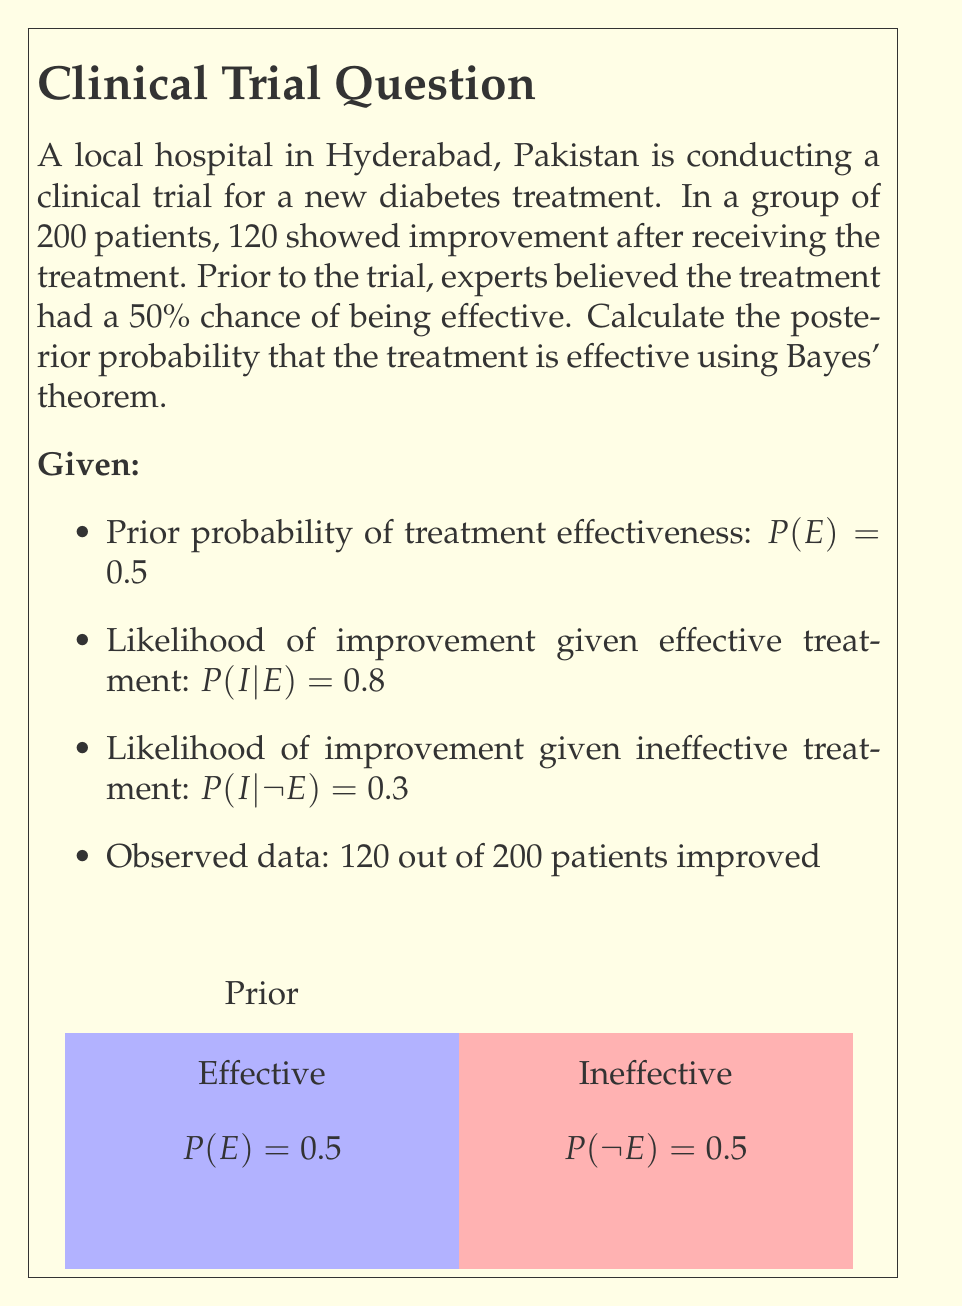Provide a solution to this math problem. Let's apply Bayes' theorem to calculate the posterior probability of the treatment being effective given the observed data:

$$P(E|I) = \frac{P(I|E) \cdot P(E)}{P(I)}$$

1. We need to calculate $P(I)$, the total probability of improvement:

   $P(I) = P(I|E) \cdot P(E) + P(I|\neg E) \cdot P(\neg E)$
   $P(I) = 0.8 \cdot 0.5 + 0.3 \cdot 0.5 = 0.4 + 0.15 = 0.55$

2. Now we can apply Bayes' theorem:

   $P(E|I) = \frac{0.8 \cdot 0.5}{0.55} = \frac{0.4}{0.55} \approx 0.7273$

3. To verify this result with the observed data:
   - Expected number of improvements if treatment is effective: $200 \cdot 0.8 = 160$
   - Expected number of improvements if treatment is ineffective: $200 \cdot 0.3 = 60$
   - Observed improvements: 120

   The observed data (120) falls between these two expectations, supporting our calculated posterior probability.

4. We can interpret this result as: Given the observed improvement in 120 out of 200 patients, there is approximately a 72.73% probability that the new diabetes treatment is effective.
Answer: $P(E|I) \approx 0.7273$ or $72.73\%$ 